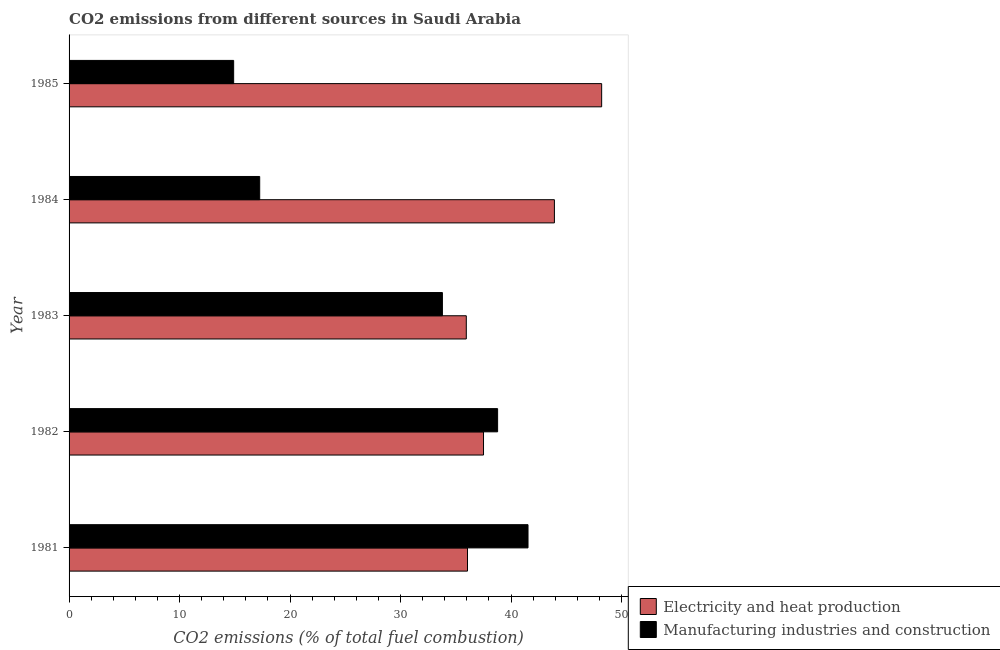How many different coloured bars are there?
Offer a terse response. 2. How many bars are there on the 1st tick from the top?
Make the answer very short. 2. How many bars are there on the 3rd tick from the bottom?
Offer a very short reply. 2. What is the label of the 5th group of bars from the top?
Your response must be concise. 1981. In how many cases, is the number of bars for a given year not equal to the number of legend labels?
Your answer should be very brief. 0. What is the co2 emissions due to electricity and heat production in 1982?
Your answer should be compact. 37.51. Across all years, what is the maximum co2 emissions due to electricity and heat production?
Your answer should be compact. 48.2. Across all years, what is the minimum co2 emissions due to electricity and heat production?
Provide a succinct answer. 35.95. In which year was the co2 emissions due to manufacturing industries minimum?
Your response must be concise. 1985. What is the total co2 emissions due to manufacturing industries in the graph?
Ensure brevity in your answer.  146.26. What is the difference between the co2 emissions due to electricity and heat production in 1982 and that in 1985?
Provide a succinct answer. -10.69. What is the difference between the co2 emissions due to electricity and heat production in 1984 and the co2 emissions due to manufacturing industries in 1983?
Make the answer very short. 10.14. What is the average co2 emissions due to electricity and heat production per year?
Give a very brief answer. 40.33. In the year 1984, what is the difference between the co2 emissions due to manufacturing industries and co2 emissions due to electricity and heat production?
Provide a short and direct response. -26.67. In how many years, is the co2 emissions due to electricity and heat production greater than 44 %?
Your answer should be compact. 1. What is the ratio of the co2 emissions due to electricity and heat production in 1982 to that in 1984?
Keep it short and to the point. 0.85. Is the co2 emissions due to manufacturing industries in 1982 less than that in 1984?
Your response must be concise. No. Is the difference between the co2 emissions due to manufacturing industries in 1982 and 1985 greater than the difference between the co2 emissions due to electricity and heat production in 1982 and 1985?
Offer a very short reply. Yes. What is the difference between the highest and the second highest co2 emissions due to electricity and heat production?
Offer a very short reply. 4.28. What is the difference between the highest and the lowest co2 emissions due to electricity and heat production?
Keep it short and to the point. 12.25. In how many years, is the co2 emissions due to manufacturing industries greater than the average co2 emissions due to manufacturing industries taken over all years?
Make the answer very short. 3. Is the sum of the co2 emissions due to manufacturing industries in 1983 and 1984 greater than the maximum co2 emissions due to electricity and heat production across all years?
Give a very brief answer. Yes. What does the 1st bar from the top in 1985 represents?
Provide a short and direct response. Manufacturing industries and construction. What does the 1st bar from the bottom in 1982 represents?
Give a very brief answer. Electricity and heat production. How many bars are there?
Ensure brevity in your answer.  10. How many years are there in the graph?
Give a very brief answer. 5. What is the difference between two consecutive major ticks on the X-axis?
Your response must be concise. 10. Are the values on the major ticks of X-axis written in scientific E-notation?
Make the answer very short. No. Does the graph contain grids?
Offer a very short reply. No. Where does the legend appear in the graph?
Ensure brevity in your answer.  Bottom right. What is the title of the graph?
Your answer should be very brief. CO2 emissions from different sources in Saudi Arabia. Does "Diarrhea" appear as one of the legend labels in the graph?
Provide a succinct answer. No. What is the label or title of the X-axis?
Ensure brevity in your answer.  CO2 emissions (% of total fuel combustion). What is the label or title of the Y-axis?
Provide a succinct answer. Year. What is the CO2 emissions (% of total fuel combustion) in Electricity and heat production in 1981?
Make the answer very short. 36.06. What is the CO2 emissions (% of total fuel combustion) in Manufacturing industries and construction in 1981?
Your answer should be very brief. 41.54. What is the CO2 emissions (% of total fuel combustion) of Electricity and heat production in 1982?
Your answer should be compact. 37.51. What is the CO2 emissions (% of total fuel combustion) in Manufacturing industries and construction in 1982?
Keep it short and to the point. 38.78. What is the CO2 emissions (% of total fuel combustion) of Electricity and heat production in 1983?
Your response must be concise. 35.95. What is the CO2 emissions (% of total fuel combustion) in Manufacturing industries and construction in 1983?
Provide a short and direct response. 33.79. What is the CO2 emissions (% of total fuel combustion) in Electricity and heat production in 1984?
Provide a succinct answer. 43.93. What is the CO2 emissions (% of total fuel combustion) of Manufacturing industries and construction in 1984?
Give a very brief answer. 17.25. What is the CO2 emissions (% of total fuel combustion) of Electricity and heat production in 1985?
Ensure brevity in your answer.  48.2. What is the CO2 emissions (% of total fuel combustion) in Manufacturing industries and construction in 1985?
Ensure brevity in your answer.  14.9. Across all years, what is the maximum CO2 emissions (% of total fuel combustion) of Electricity and heat production?
Your answer should be very brief. 48.2. Across all years, what is the maximum CO2 emissions (% of total fuel combustion) in Manufacturing industries and construction?
Offer a terse response. 41.54. Across all years, what is the minimum CO2 emissions (% of total fuel combustion) in Electricity and heat production?
Make the answer very short. 35.95. Across all years, what is the minimum CO2 emissions (% of total fuel combustion) of Manufacturing industries and construction?
Your answer should be very brief. 14.9. What is the total CO2 emissions (% of total fuel combustion) of Electricity and heat production in the graph?
Provide a short and direct response. 201.64. What is the total CO2 emissions (% of total fuel combustion) of Manufacturing industries and construction in the graph?
Ensure brevity in your answer.  146.26. What is the difference between the CO2 emissions (% of total fuel combustion) of Electricity and heat production in 1981 and that in 1982?
Your answer should be compact. -1.45. What is the difference between the CO2 emissions (% of total fuel combustion) in Manufacturing industries and construction in 1981 and that in 1982?
Provide a succinct answer. 2.75. What is the difference between the CO2 emissions (% of total fuel combustion) of Electricity and heat production in 1981 and that in 1983?
Keep it short and to the point. 0.11. What is the difference between the CO2 emissions (% of total fuel combustion) of Manufacturing industries and construction in 1981 and that in 1983?
Make the answer very short. 7.75. What is the difference between the CO2 emissions (% of total fuel combustion) of Electricity and heat production in 1981 and that in 1984?
Keep it short and to the point. -7.87. What is the difference between the CO2 emissions (% of total fuel combustion) in Manufacturing industries and construction in 1981 and that in 1984?
Provide a short and direct response. 24.28. What is the difference between the CO2 emissions (% of total fuel combustion) in Electricity and heat production in 1981 and that in 1985?
Your answer should be very brief. -12.14. What is the difference between the CO2 emissions (% of total fuel combustion) of Manufacturing industries and construction in 1981 and that in 1985?
Your answer should be very brief. 26.64. What is the difference between the CO2 emissions (% of total fuel combustion) of Electricity and heat production in 1982 and that in 1983?
Your answer should be very brief. 1.56. What is the difference between the CO2 emissions (% of total fuel combustion) in Manufacturing industries and construction in 1982 and that in 1983?
Your answer should be very brief. 5. What is the difference between the CO2 emissions (% of total fuel combustion) of Electricity and heat production in 1982 and that in 1984?
Offer a very short reply. -6.42. What is the difference between the CO2 emissions (% of total fuel combustion) of Manufacturing industries and construction in 1982 and that in 1984?
Offer a very short reply. 21.53. What is the difference between the CO2 emissions (% of total fuel combustion) in Electricity and heat production in 1982 and that in 1985?
Offer a very short reply. -10.69. What is the difference between the CO2 emissions (% of total fuel combustion) of Manufacturing industries and construction in 1982 and that in 1985?
Offer a terse response. 23.89. What is the difference between the CO2 emissions (% of total fuel combustion) of Electricity and heat production in 1983 and that in 1984?
Ensure brevity in your answer.  -7.97. What is the difference between the CO2 emissions (% of total fuel combustion) in Manufacturing industries and construction in 1983 and that in 1984?
Give a very brief answer. 16.54. What is the difference between the CO2 emissions (% of total fuel combustion) in Electricity and heat production in 1983 and that in 1985?
Offer a terse response. -12.25. What is the difference between the CO2 emissions (% of total fuel combustion) in Manufacturing industries and construction in 1983 and that in 1985?
Offer a terse response. 18.89. What is the difference between the CO2 emissions (% of total fuel combustion) in Electricity and heat production in 1984 and that in 1985?
Make the answer very short. -4.28. What is the difference between the CO2 emissions (% of total fuel combustion) in Manufacturing industries and construction in 1984 and that in 1985?
Make the answer very short. 2.36. What is the difference between the CO2 emissions (% of total fuel combustion) of Electricity and heat production in 1981 and the CO2 emissions (% of total fuel combustion) of Manufacturing industries and construction in 1982?
Offer a terse response. -2.73. What is the difference between the CO2 emissions (% of total fuel combustion) in Electricity and heat production in 1981 and the CO2 emissions (% of total fuel combustion) in Manufacturing industries and construction in 1983?
Make the answer very short. 2.27. What is the difference between the CO2 emissions (% of total fuel combustion) in Electricity and heat production in 1981 and the CO2 emissions (% of total fuel combustion) in Manufacturing industries and construction in 1984?
Ensure brevity in your answer.  18.81. What is the difference between the CO2 emissions (% of total fuel combustion) of Electricity and heat production in 1981 and the CO2 emissions (% of total fuel combustion) of Manufacturing industries and construction in 1985?
Offer a very short reply. 21.16. What is the difference between the CO2 emissions (% of total fuel combustion) of Electricity and heat production in 1982 and the CO2 emissions (% of total fuel combustion) of Manufacturing industries and construction in 1983?
Give a very brief answer. 3.72. What is the difference between the CO2 emissions (% of total fuel combustion) of Electricity and heat production in 1982 and the CO2 emissions (% of total fuel combustion) of Manufacturing industries and construction in 1984?
Provide a succinct answer. 20.26. What is the difference between the CO2 emissions (% of total fuel combustion) in Electricity and heat production in 1982 and the CO2 emissions (% of total fuel combustion) in Manufacturing industries and construction in 1985?
Your answer should be compact. 22.61. What is the difference between the CO2 emissions (% of total fuel combustion) of Electricity and heat production in 1983 and the CO2 emissions (% of total fuel combustion) of Manufacturing industries and construction in 1984?
Provide a succinct answer. 18.7. What is the difference between the CO2 emissions (% of total fuel combustion) of Electricity and heat production in 1983 and the CO2 emissions (% of total fuel combustion) of Manufacturing industries and construction in 1985?
Your answer should be compact. 21.06. What is the difference between the CO2 emissions (% of total fuel combustion) of Electricity and heat production in 1984 and the CO2 emissions (% of total fuel combustion) of Manufacturing industries and construction in 1985?
Ensure brevity in your answer.  29.03. What is the average CO2 emissions (% of total fuel combustion) of Electricity and heat production per year?
Keep it short and to the point. 40.33. What is the average CO2 emissions (% of total fuel combustion) in Manufacturing industries and construction per year?
Provide a succinct answer. 29.25. In the year 1981, what is the difference between the CO2 emissions (% of total fuel combustion) of Electricity and heat production and CO2 emissions (% of total fuel combustion) of Manufacturing industries and construction?
Make the answer very short. -5.48. In the year 1982, what is the difference between the CO2 emissions (% of total fuel combustion) in Electricity and heat production and CO2 emissions (% of total fuel combustion) in Manufacturing industries and construction?
Offer a terse response. -1.28. In the year 1983, what is the difference between the CO2 emissions (% of total fuel combustion) of Electricity and heat production and CO2 emissions (% of total fuel combustion) of Manufacturing industries and construction?
Offer a terse response. 2.16. In the year 1984, what is the difference between the CO2 emissions (% of total fuel combustion) of Electricity and heat production and CO2 emissions (% of total fuel combustion) of Manufacturing industries and construction?
Make the answer very short. 26.67. In the year 1985, what is the difference between the CO2 emissions (% of total fuel combustion) in Electricity and heat production and CO2 emissions (% of total fuel combustion) in Manufacturing industries and construction?
Ensure brevity in your answer.  33.31. What is the ratio of the CO2 emissions (% of total fuel combustion) of Electricity and heat production in 1981 to that in 1982?
Provide a succinct answer. 0.96. What is the ratio of the CO2 emissions (% of total fuel combustion) of Manufacturing industries and construction in 1981 to that in 1982?
Provide a short and direct response. 1.07. What is the ratio of the CO2 emissions (% of total fuel combustion) of Electricity and heat production in 1981 to that in 1983?
Your response must be concise. 1. What is the ratio of the CO2 emissions (% of total fuel combustion) in Manufacturing industries and construction in 1981 to that in 1983?
Provide a succinct answer. 1.23. What is the ratio of the CO2 emissions (% of total fuel combustion) in Electricity and heat production in 1981 to that in 1984?
Offer a terse response. 0.82. What is the ratio of the CO2 emissions (% of total fuel combustion) in Manufacturing industries and construction in 1981 to that in 1984?
Your response must be concise. 2.41. What is the ratio of the CO2 emissions (% of total fuel combustion) of Electricity and heat production in 1981 to that in 1985?
Your answer should be compact. 0.75. What is the ratio of the CO2 emissions (% of total fuel combustion) of Manufacturing industries and construction in 1981 to that in 1985?
Ensure brevity in your answer.  2.79. What is the ratio of the CO2 emissions (% of total fuel combustion) in Electricity and heat production in 1982 to that in 1983?
Offer a terse response. 1.04. What is the ratio of the CO2 emissions (% of total fuel combustion) in Manufacturing industries and construction in 1982 to that in 1983?
Provide a short and direct response. 1.15. What is the ratio of the CO2 emissions (% of total fuel combustion) in Electricity and heat production in 1982 to that in 1984?
Make the answer very short. 0.85. What is the ratio of the CO2 emissions (% of total fuel combustion) of Manufacturing industries and construction in 1982 to that in 1984?
Ensure brevity in your answer.  2.25. What is the ratio of the CO2 emissions (% of total fuel combustion) in Electricity and heat production in 1982 to that in 1985?
Your response must be concise. 0.78. What is the ratio of the CO2 emissions (% of total fuel combustion) of Manufacturing industries and construction in 1982 to that in 1985?
Provide a short and direct response. 2.6. What is the ratio of the CO2 emissions (% of total fuel combustion) of Electricity and heat production in 1983 to that in 1984?
Ensure brevity in your answer.  0.82. What is the ratio of the CO2 emissions (% of total fuel combustion) of Manufacturing industries and construction in 1983 to that in 1984?
Give a very brief answer. 1.96. What is the ratio of the CO2 emissions (% of total fuel combustion) of Electricity and heat production in 1983 to that in 1985?
Offer a terse response. 0.75. What is the ratio of the CO2 emissions (% of total fuel combustion) of Manufacturing industries and construction in 1983 to that in 1985?
Make the answer very short. 2.27. What is the ratio of the CO2 emissions (% of total fuel combustion) of Electricity and heat production in 1984 to that in 1985?
Provide a succinct answer. 0.91. What is the ratio of the CO2 emissions (% of total fuel combustion) of Manufacturing industries and construction in 1984 to that in 1985?
Provide a succinct answer. 1.16. What is the difference between the highest and the second highest CO2 emissions (% of total fuel combustion) in Electricity and heat production?
Keep it short and to the point. 4.28. What is the difference between the highest and the second highest CO2 emissions (% of total fuel combustion) of Manufacturing industries and construction?
Provide a short and direct response. 2.75. What is the difference between the highest and the lowest CO2 emissions (% of total fuel combustion) in Electricity and heat production?
Make the answer very short. 12.25. What is the difference between the highest and the lowest CO2 emissions (% of total fuel combustion) in Manufacturing industries and construction?
Offer a very short reply. 26.64. 